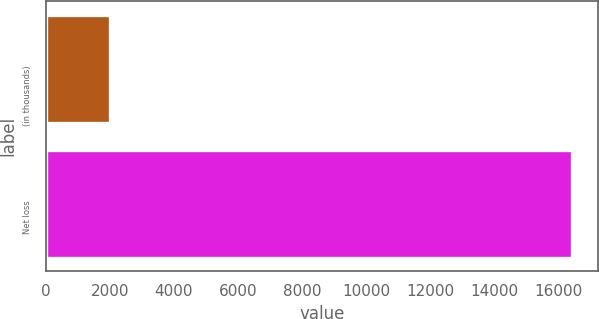Convert chart to OTSL. <chart><loc_0><loc_0><loc_500><loc_500><bar_chart><fcel>(in thousands)<fcel>Net loss<nl><fcel>2007<fcel>16425<nl></chart> 